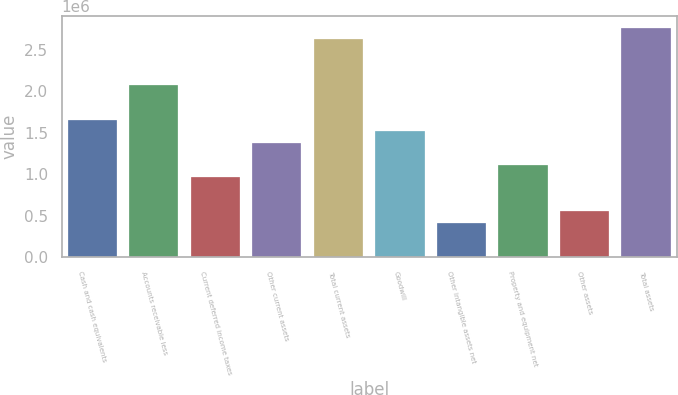Convert chart. <chart><loc_0><loc_0><loc_500><loc_500><bar_chart><fcel>Cash and cash equivalents<fcel>Accounts receivable less<fcel>Current deferred income taxes<fcel>Other current assets<fcel>Total current assets<fcel>Goodwill<fcel>Other intangible assets net<fcel>Property and equipment net<fcel>Other assets<fcel>Total assets<nl><fcel>1.6575e+06<fcel>2.07185e+06<fcel>966925<fcel>1.38127e+06<fcel>2.62431e+06<fcel>1.51939e+06<fcel>414463<fcel>1.10504e+06<fcel>552579<fcel>2.76242e+06<nl></chart> 